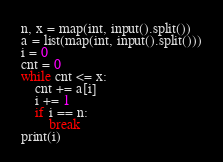<code> <loc_0><loc_0><loc_500><loc_500><_Python_>n, x = map(int, input().split())
a = list(map(int, input().split()))
i = 0
cnt = 0
while cnt <= x:
    cnt += a[i]
    i += 1
    if i == n:
        break
print(i)    </code> 